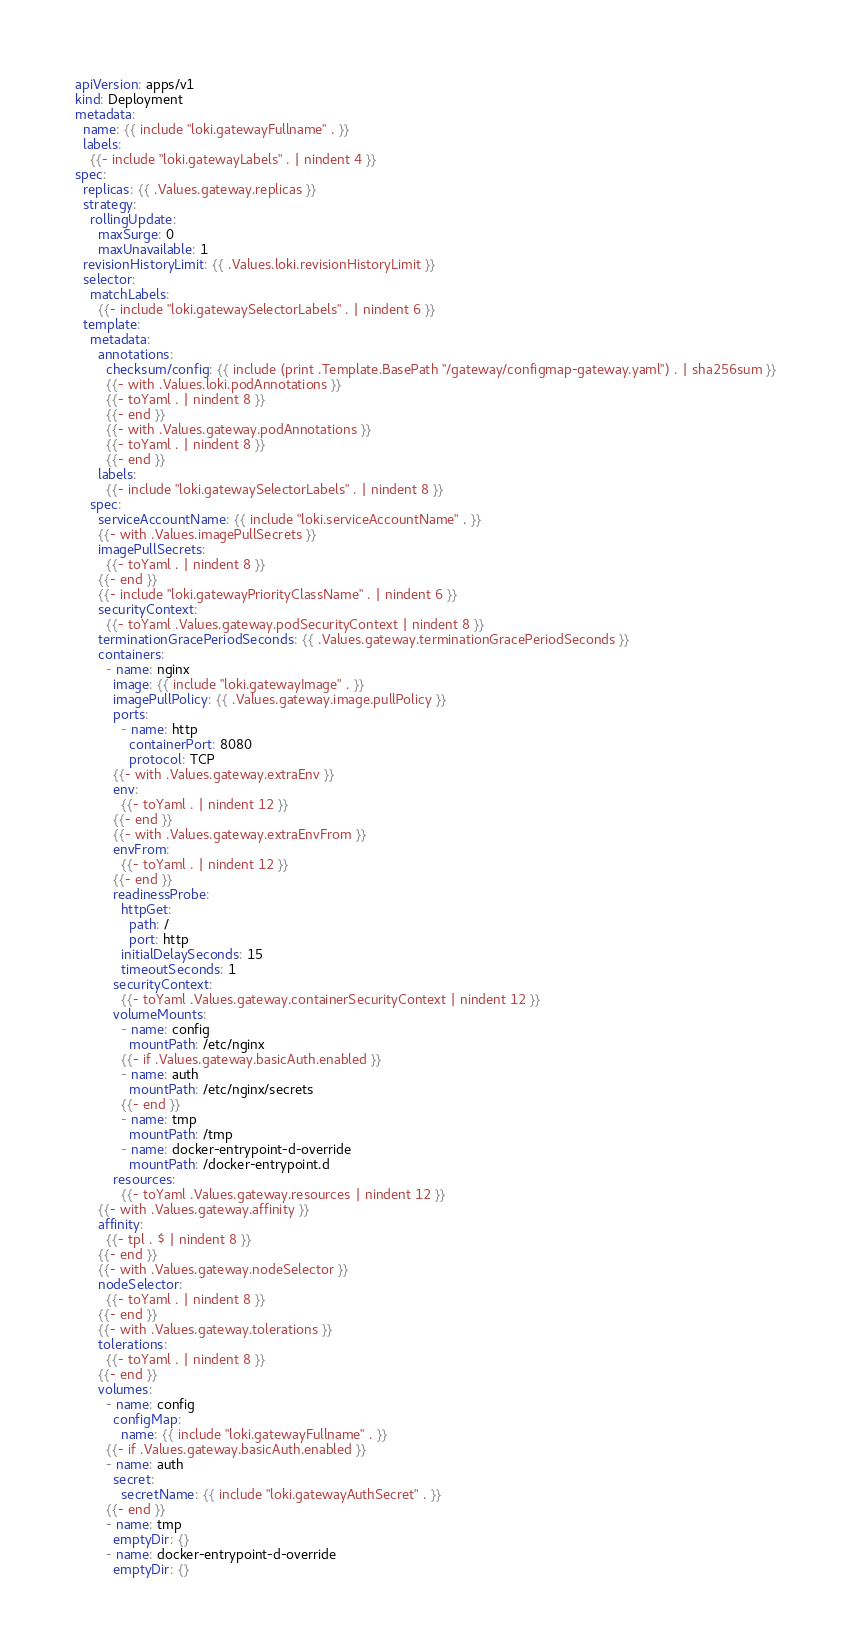<code> <loc_0><loc_0><loc_500><loc_500><_YAML_>apiVersion: apps/v1
kind: Deployment
metadata:
  name: {{ include "loki.gatewayFullname" . }}
  labels:
    {{- include "loki.gatewayLabels" . | nindent 4 }}
spec:
  replicas: {{ .Values.gateway.replicas }}
  strategy:
    rollingUpdate:
      maxSurge: 0
      maxUnavailable: 1
  revisionHistoryLimit: {{ .Values.loki.revisionHistoryLimit }}
  selector:
    matchLabels:
      {{- include "loki.gatewaySelectorLabels" . | nindent 6 }}
  template:
    metadata:
      annotations:
        checksum/config: {{ include (print .Template.BasePath "/gateway/configmap-gateway.yaml") . | sha256sum }}
        {{- with .Values.loki.podAnnotations }}
        {{- toYaml . | nindent 8 }}
        {{- end }}
        {{- with .Values.gateway.podAnnotations }}
        {{- toYaml . | nindent 8 }}
        {{- end }}
      labels:
        {{- include "loki.gatewaySelectorLabels" . | nindent 8 }}
    spec:
      serviceAccountName: {{ include "loki.serviceAccountName" . }}
      {{- with .Values.imagePullSecrets }}
      imagePullSecrets:
        {{- toYaml . | nindent 8 }}
      {{- end }}
      {{- include "loki.gatewayPriorityClassName" . | nindent 6 }}
      securityContext:
        {{- toYaml .Values.gateway.podSecurityContext | nindent 8 }}
      terminationGracePeriodSeconds: {{ .Values.gateway.terminationGracePeriodSeconds }}
      containers:
        - name: nginx
          image: {{ include "loki.gatewayImage" . }}
          imagePullPolicy: {{ .Values.gateway.image.pullPolicy }}
          ports:
            - name: http
              containerPort: 8080
              protocol: TCP
          {{- with .Values.gateway.extraEnv }}
          env:
            {{- toYaml . | nindent 12 }}
          {{- end }}
          {{- with .Values.gateway.extraEnvFrom }}
          envFrom:
            {{- toYaml . | nindent 12 }}
          {{- end }}
          readinessProbe:
            httpGet:
              path: /
              port: http
            initialDelaySeconds: 15
            timeoutSeconds: 1
          securityContext:
            {{- toYaml .Values.gateway.containerSecurityContext | nindent 12 }}
          volumeMounts:
            - name: config
              mountPath: /etc/nginx
            {{- if .Values.gateway.basicAuth.enabled }}
            - name: auth
              mountPath: /etc/nginx/secrets
            {{- end }}
            - name: tmp
              mountPath: /tmp
            - name: docker-entrypoint-d-override
              mountPath: /docker-entrypoint.d
          resources:
            {{- toYaml .Values.gateway.resources | nindent 12 }}
      {{- with .Values.gateway.affinity }}
      affinity:
        {{- tpl . $ | nindent 8 }}
      {{- end }}
      {{- with .Values.gateway.nodeSelector }}
      nodeSelector:
        {{- toYaml . | nindent 8 }}
      {{- end }}
      {{- with .Values.gateway.tolerations }}
      tolerations:
        {{- toYaml . | nindent 8 }}
      {{- end }}
      volumes:
        - name: config
          configMap:
            name: {{ include "loki.gatewayFullname" . }}
        {{- if .Values.gateway.basicAuth.enabled }}
        - name: auth
          secret:
            secretName: {{ include "loki.gatewayAuthSecret" . }}
        {{- end }}
        - name: tmp
          emptyDir: {}
        - name: docker-entrypoint-d-override
          emptyDir: {}
</code> 